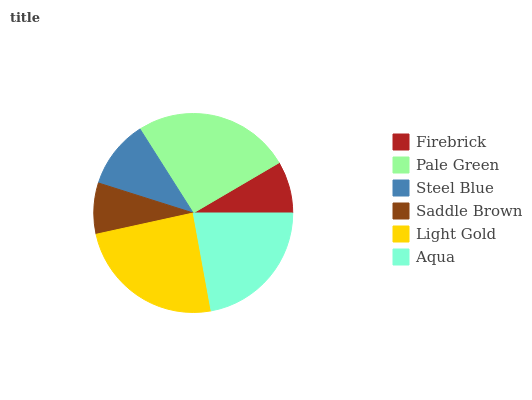Is Saddle Brown the minimum?
Answer yes or no. Yes. Is Pale Green the maximum?
Answer yes or no. Yes. Is Steel Blue the minimum?
Answer yes or no. No. Is Steel Blue the maximum?
Answer yes or no. No. Is Pale Green greater than Steel Blue?
Answer yes or no. Yes. Is Steel Blue less than Pale Green?
Answer yes or no. Yes. Is Steel Blue greater than Pale Green?
Answer yes or no. No. Is Pale Green less than Steel Blue?
Answer yes or no. No. Is Aqua the high median?
Answer yes or no. Yes. Is Steel Blue the low median?
Answer yes or no. Yes. Is Firebrick the high median?
Answer yes or no. No. Is Light Gold the low median?
Answer yes or no. No. 